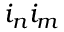Convert formula to latex. <formula><loc_0><loc_0><loc_500><loc_500>i _ { n } i _ { m }</formula> 